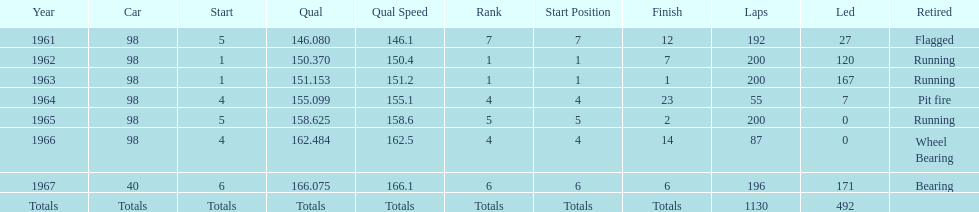What is the difference between the qualfying time in 1967 and 1965? 7.45. 